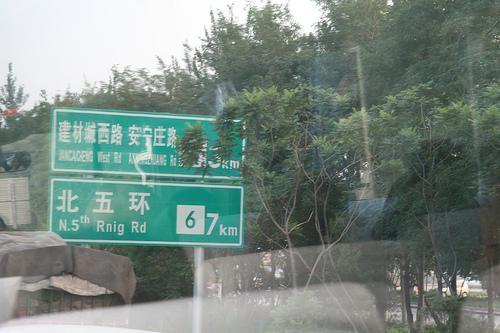How many signs are pictured?
Give a very brief answer. 2. How many people appear in this picture?
Give a very brief answer. 0. 